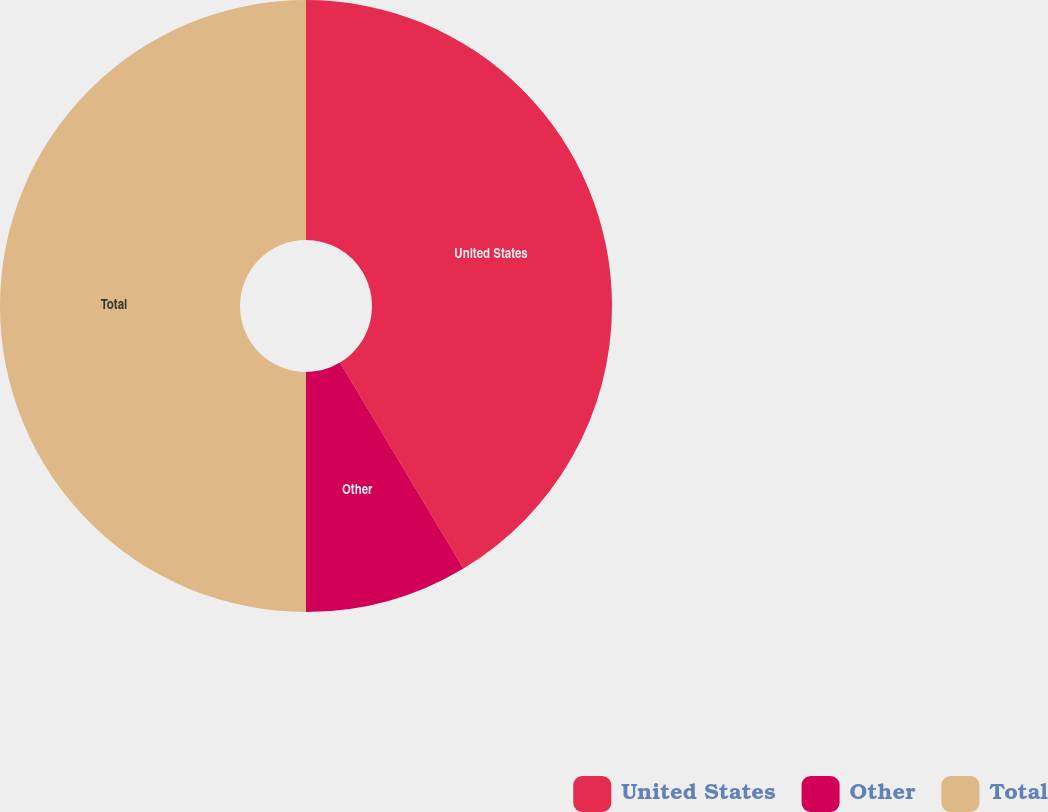Convert chart. <chart><loc_0><loc_0><loc_500><loc_500><pie_chart><fcel>United States<fcel>Other<fcel>Total<nl><fcel>41.4%<fcel>8.6%<fcel>50.0%<nl></chart> 